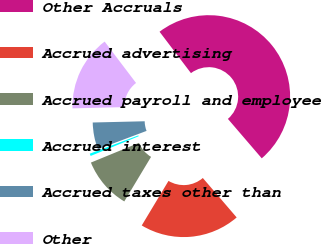Convert chart to OTSL. <chart><loc_0><loc_0><loc_500><loc_500><pie_chart><fcel>Other Accruals<fcel>Accrued advertising<fcel>Accrued payroll and employee<fcel>Accrued interest<fcel>Accrued taxes other than<fcel>Other<nl><fcel>49.04%<fcel>19.9%<fcel>10.19%<fcel>0.48%<fcel>5.34%<fcel>15.05%<nl></chart> 